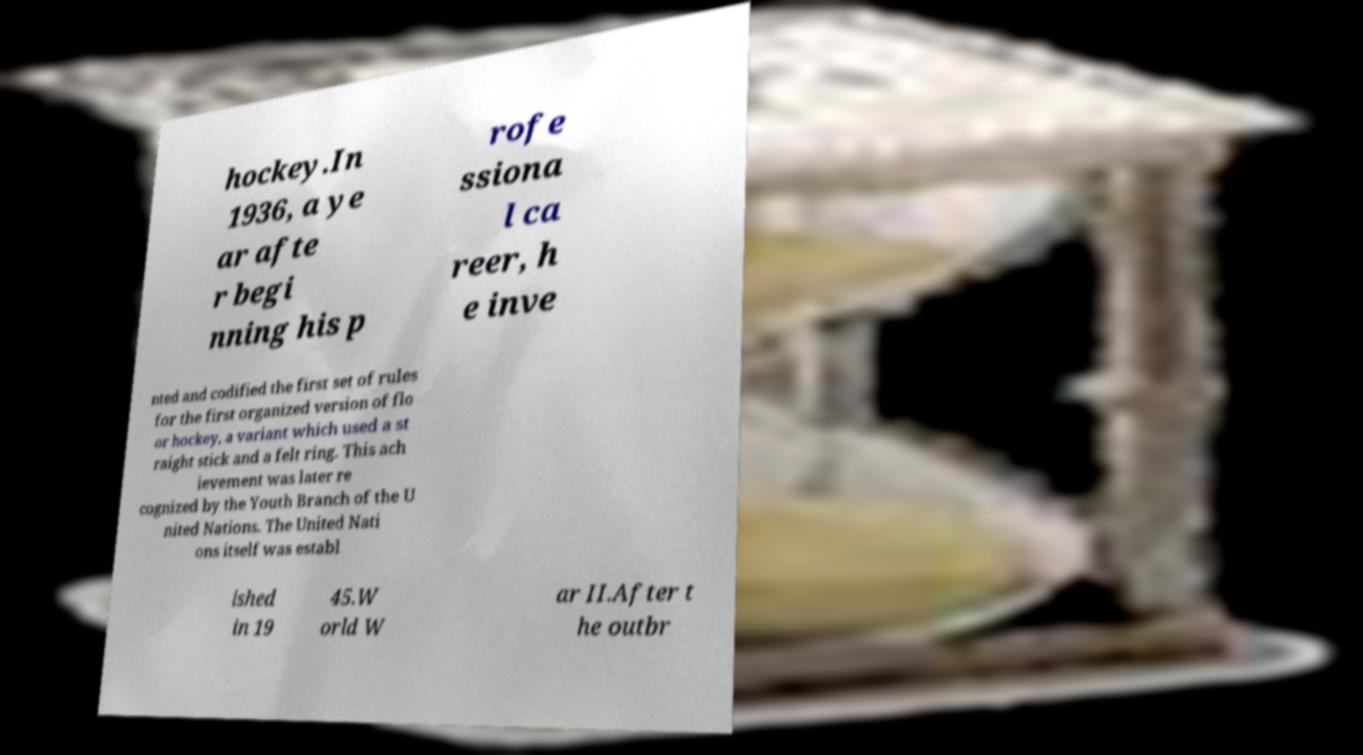Could you assist in decoding the text presented in this image and type it out clearly? hockey.In 1936, a ye ar afte r begi nning his p rofe ssiona l ca reer, h e inve nted and codified the first set of rules for the first organized version of flo or hockey, a variant which used a st raight stick and a felt ring. This ach ievement was later re cognized by the Youth Branch of the U nited Nations. The United Nati ons itself was establ ished in 19 45.W orld W ar II.After t he outbr 